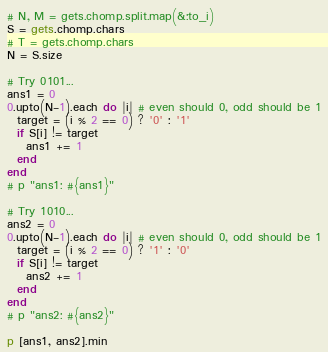<code> <loc_0><loc_0><loc_500><loc_500><_Ruby_># N, M = gets.chomp.split.map(&:to_i)
S = gets.chomp.chars
# T = gets.chomp.chars
N = S.size

# Try 0101...
ans1 = 0
0.upto(N-1).each do |i| # even should 0, odd should be 1
  target = (i % 2 == 0) ? '0' : '1'
  if S[i] != target
    ans1 += 1
  end
end
# p "ans1: #{ans1}"

# Try 1010...
ans2 = 0
0.upto(N-1).each do |i| # even should 0, odd should be 1
  target = (i % 2 == 0) ? '1' : '0'
  if S[i] != target
    ans2 += 1
  end
end
# p "ans2: #{ans2}"

p [ans1, ans2].min</code> 